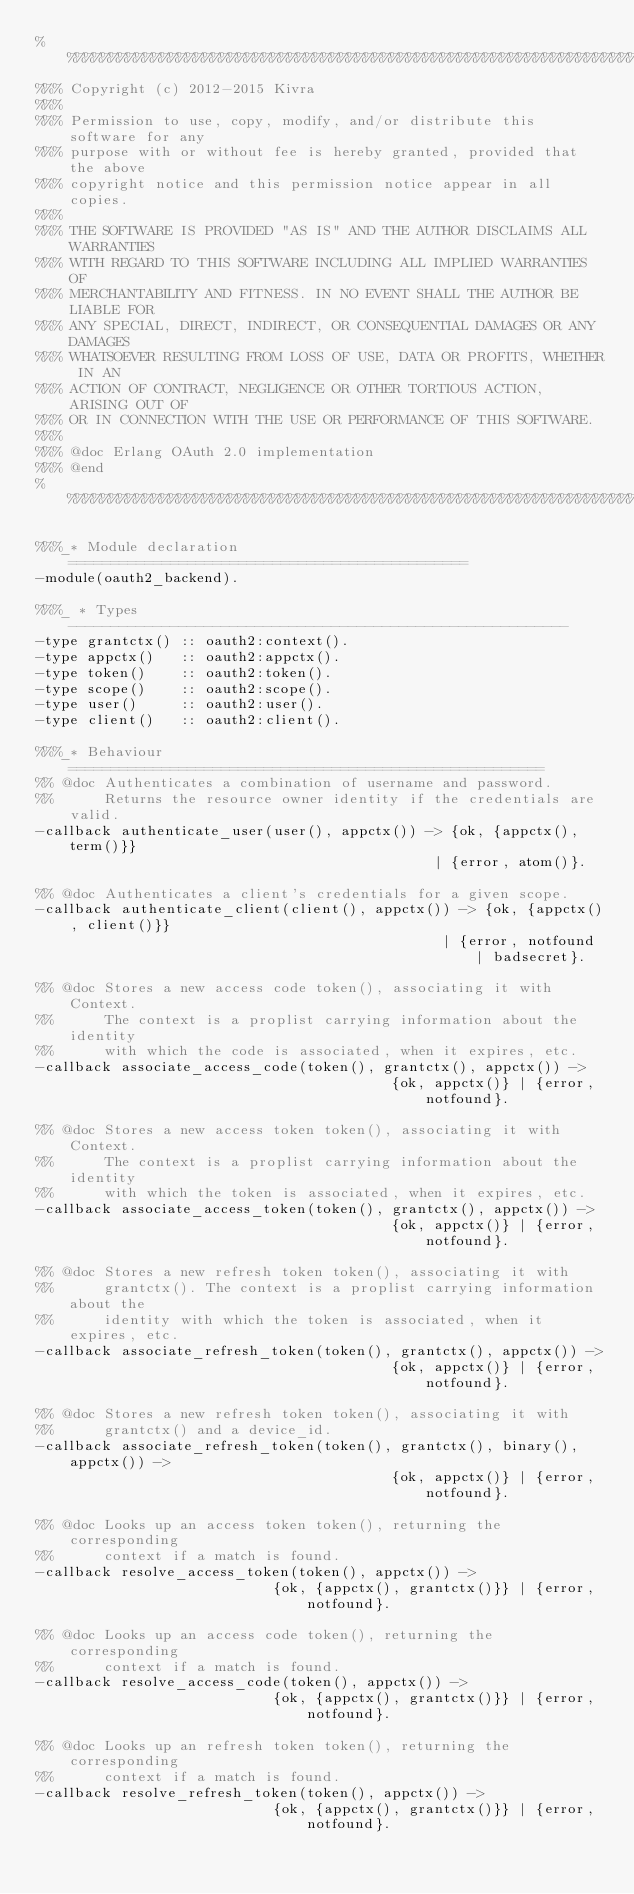<code> <loc_0><loc_0><loc_500><loc_500><_Erlang_>%%%%%%%%%%%%%%%%%%%%%%%%%%%%%%%%%%%%%%%%%%%%%%%%%%%%%%%%%%%%%%%%%%%%%%%%%%%%%%%
%%% Copyright (c) 2012-2015 Kivra
%%%
%%% Permission to use, copy, modify, and/or distribute this software for any
%%% purpose with or without fee is hereby granted, provided that the above
%%% copyright notice and this permission notice appear in all copies.
%%%
%%% THE SOFTWARE IS PROVIDED "AS IS" AND THE AUTHOR DISCLAIMS ALL WARRANTIES
%%% WITH REGARD TO THIS SOFTWARE INCLUDING ALL IMPLIED WARRANTIES OF
%%% MERCHANTABILITY AND FITNESS. IN NO EVENT SHALL THE AUTHOR BE LIABLE FOR
%%% ANY SPECIAL, DIRECT, INDIRECT, OR CONSEQUENTIAL DAMAGES OR ANY DAMAGES
%%% WHATSOEVER RESULTING FROM LOSS OF USE, DATA OR PROFITS, WHETHER IN AN
%%% ACTION OF CONTRACT, NEGLIGENCE OR OTHER TORTIOUS ACTION, ARISING OUT OF
%%% OR IN CONNECTION WITH THE USE OR PERFORMANCE OF THIS SOFTWARE.
%%%
%%% @doc Erlang OAuth 2.0 implementation
%%% @end
%%%%%%%%%%%%%%%%%%%%%%%%%%%%%%%%%%%%%%%%%%%%%%%%%%%%%%%%%%%%%%%%%%%%%%%%%%%%%%%

%%%_* Module declaration ===============================================
-module(oauth2_backend).

%%%_ * Types -----------------------------------------------------------
-type grantctx() :: oauth2:context().
-type appctx()   :: oauth2:appctx().
-type token()    :: oauth2:token().
-type scope()    :: oauth2:scope().
-type user()     :: oauth2:user().
-type client()   :: oauth2:client().

%%%_* Behaviour ========================================================
%% @doc Authenticates a combination of username and password.
%%      Returns the resource owner identity if the credentials are valid.
-callback authenticate_user(user(), appctx()) -> {ok, {appctx(), term()}}
                                               | {error, atom()}.

%% @doc Authenticates a client's credentials for a given scope.
-callback authenticate_client(client(), appctx()) -> {ok, {appctx(), client()}}
                                                | {error, notfound | badsecret}.

%% @doc Stores a new access code token(), associating it with Context.
%%      The context is a proplist carrying information about the identity
%%      with which the code is associated, when it expires, etc.
-callback associate_access_code(token(), grantctx(), appctx()) ->
                                          {ok, appctx()} | {error, notfound}.

%% @doc Stores a new access token token(), associating it with Context.
%%      The context is a proplist carrying information about the identity
%%      with which the token is associated, when it expires, etc.
-callback associate_access_token(token(), grantctx(), appctx()) ->
                                          {ok, appctx()} | {error, notfound}.

%% @doc Stores a new refresh token token(), associating it with
%%      grantctx(). The context is a proplist carrying information about the
%%      identity with which the token is associated, when it expires, etc.
-callback associate_refresh_token(token(), grantctx(), appctx()) ->
                                          {ok, appctx()} | {error, notfound}.

%% @doc Stores a new refresh token token(), associating it with
%%      grantctx() and a device_id.
-callback associate_refresh_token(token(), grantctx(), binary(), appctx()) ->
                                          {ok, appctx()} | {error, notfound}.

%% @doc Looks up an access token token(), returning the corresponding
%%      context if a match is found.
-callback resolve_access_token(token(), appctx()) ->
                            {ok, {appctx(), grantctx()}} | {error, notfound}.

%% @doc Looks up an access code token(), returning the corresponding
%%      context if a match is found.
-callback resolve_access_code(token(), appctx()) ->
                            {ok, {appctx(), grantctx()}} | {error, notfound}.

%% @doc Looks up an refresh token token(), returning the corresponding
%%      context if a match is found.
-callback resolve_refresh_token(token(), appctx()) ->
                            {ok, {appctx(), grantctx()}} | {error, notfound}.
</code> 